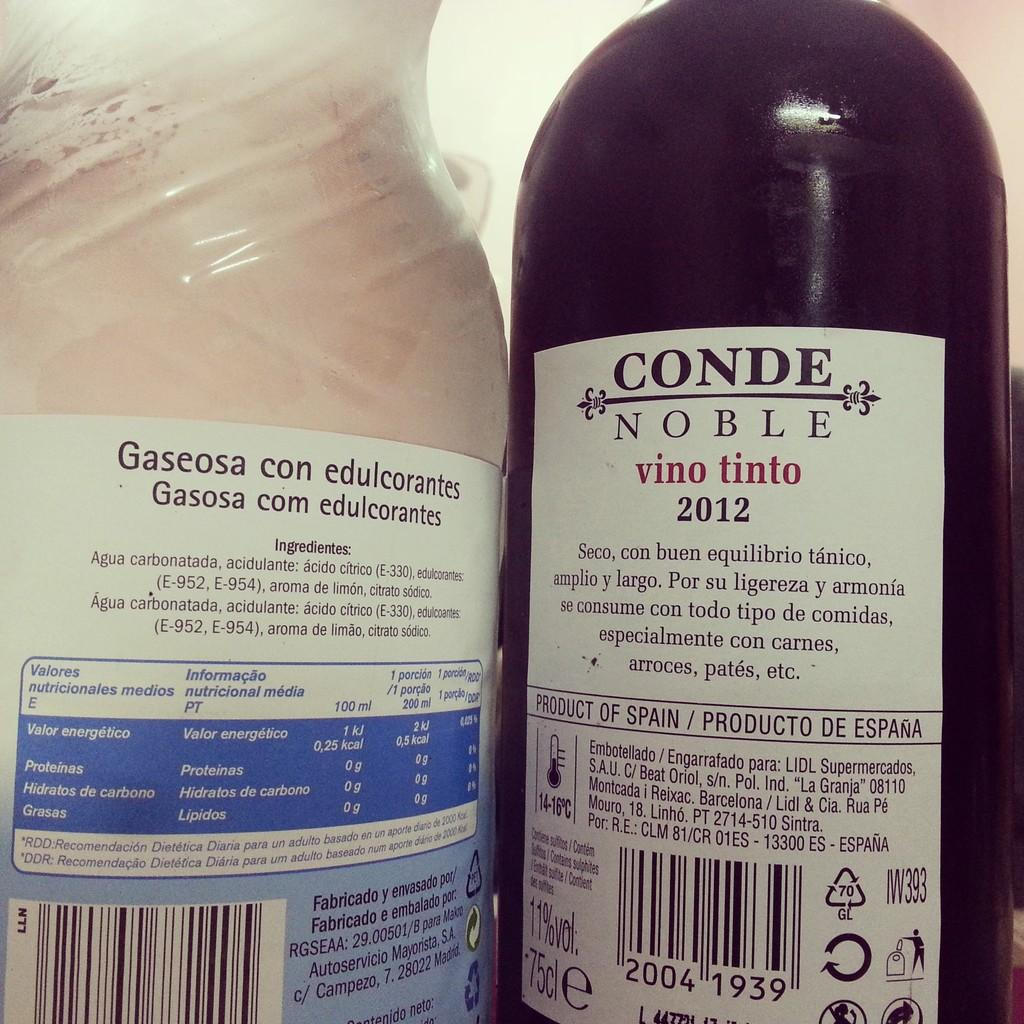Provide a one-sentence caption for the provided image. The back label of a bottle of Conde Noble wine shows it is a product of Spain. 